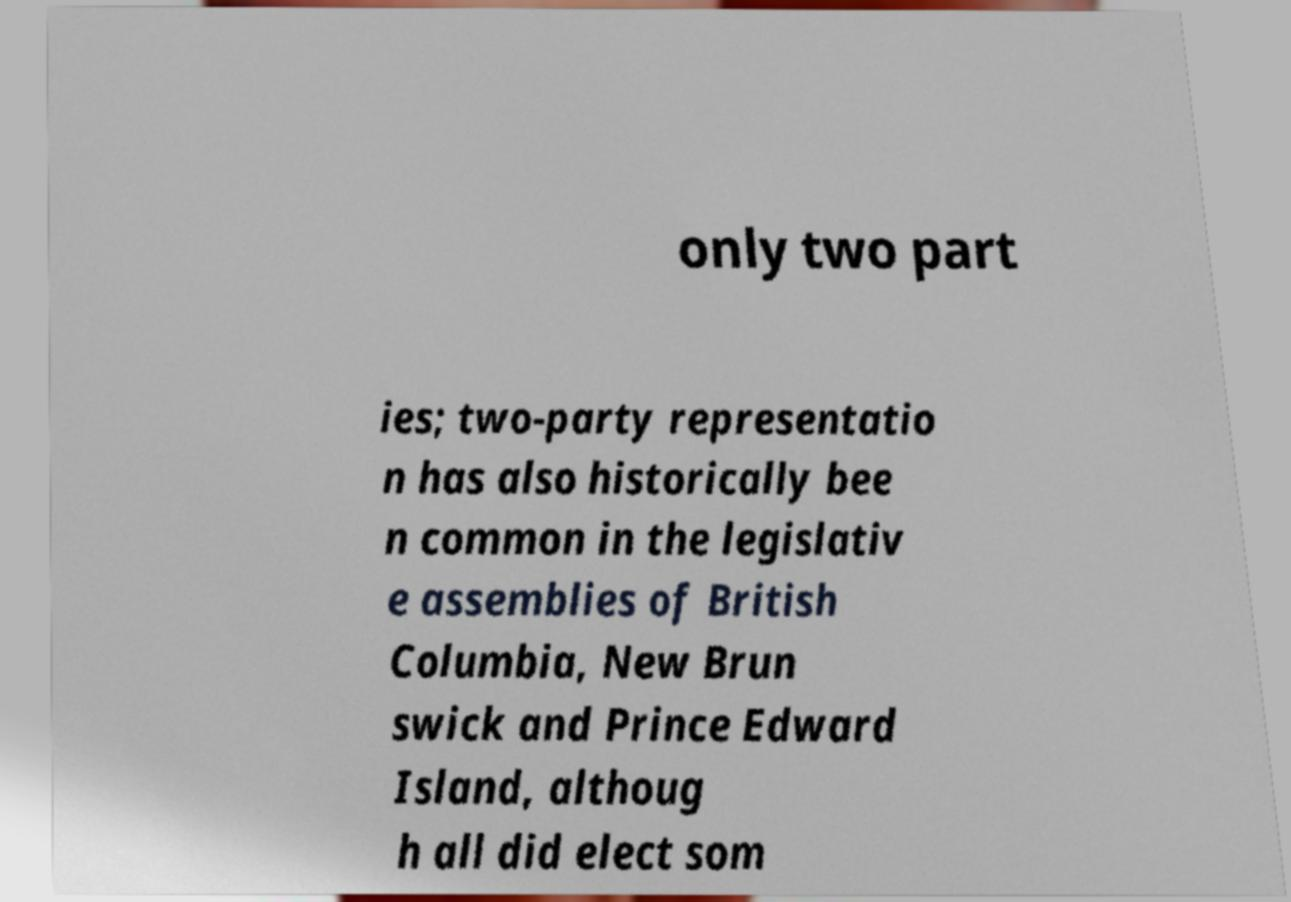Could you extract and type out the text from this image? only two part ies; two-party representatio n has also historically bee n common in the legislativ e assemblies of British Columbia, New Brun swick and Prince Edward Island, althoug h all did elect som 